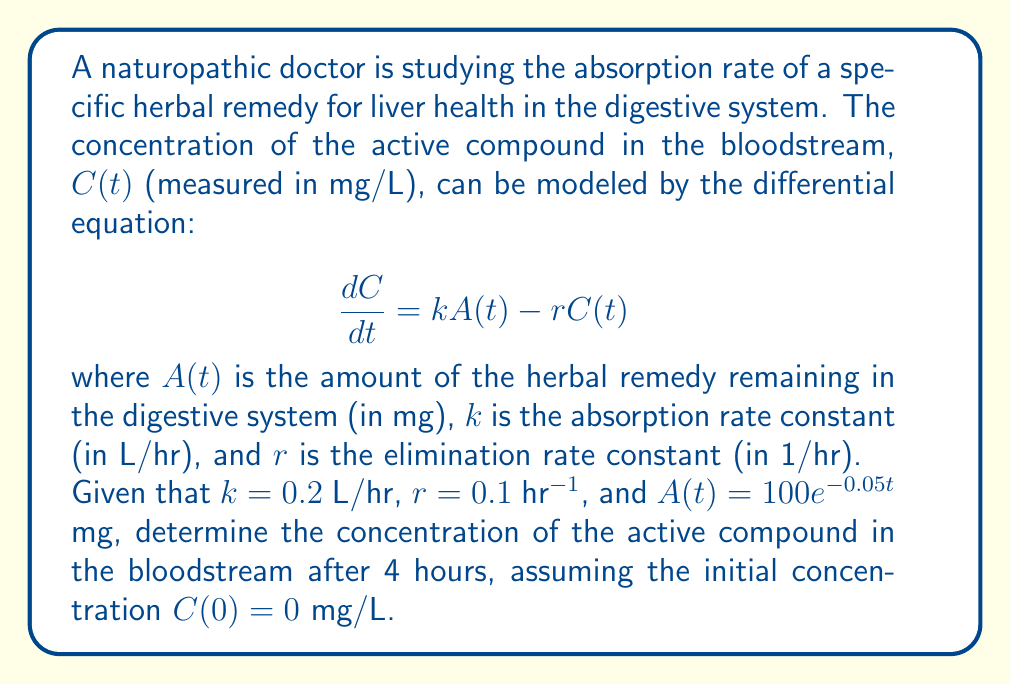Show me your answer to this math problem. Let's solve this problem step by step:

1) We are given the differential equation:
   $$\frac{dC}{dt} = kA(t) - rC(t)$$

2) We know that $k = 0.2$ L/hr, $r = 0.1$ hr$^{-1}$, and $A(t) = 100e^{-0.05t}$ mg.

3) Substituting these values into the differential equation:
   $$\frac{dC}{dt} = 0.2(100e^{-0.05t}) - 0.1C(t)$$
   $$\frac{dC}{dt} = 20e^{-0.05t} - 0.1C(t)$$

4) This is a first-order linear differential equation of the form:
   $$\frac{dC}{dt} + 0.1C = 20e^{-0.05t}$$

5) The general solution for this type of equation is:
   $$C(t) = e^{-0.1t}\left(\int 20e^{-0.05t}e^{0.1t}dt + K\right)$$

6) Solving the integral:
   $$C(t) = e^{-0.1t}\left(20\int e^{0.05t}dt + K\right)$$
   $$C(t) = e^{-0.1t}\left(\frac{400}{0.05}e^{0.05t} + K\right)$$
   $$C(t) = 400e^{-0.05t} + Ke^{-0.1t}$$

7) Using the initial condition $C(0) = 0$:
   $$0 = 400 + K$$
   $$K = -400$$

8) Therefore, the particular solution is:
   $$C(t) = 400e^{-0.05t} - 400e^{-0.1t}$$

9) To find the concentration after 4 hours, we substitute $t = 4$:
   $$C(4) = 400e^{-0.05(4)} - 400e^{-0.1(4)}$$
   $$C(4) = 400e^{-0.2} - 400e^{-0.4}$$
   $$C(4) = 400(0.8187) - 400(0.6703)$$
   $$C(4) = 327.48 - 268.12$$
   $$C(4) = 59.36$$

Therefore, the concentration of the active compound in the bloodstream after 4 hours is approximately 59.36 mg/L.
Answer: 59.36 mg/L 